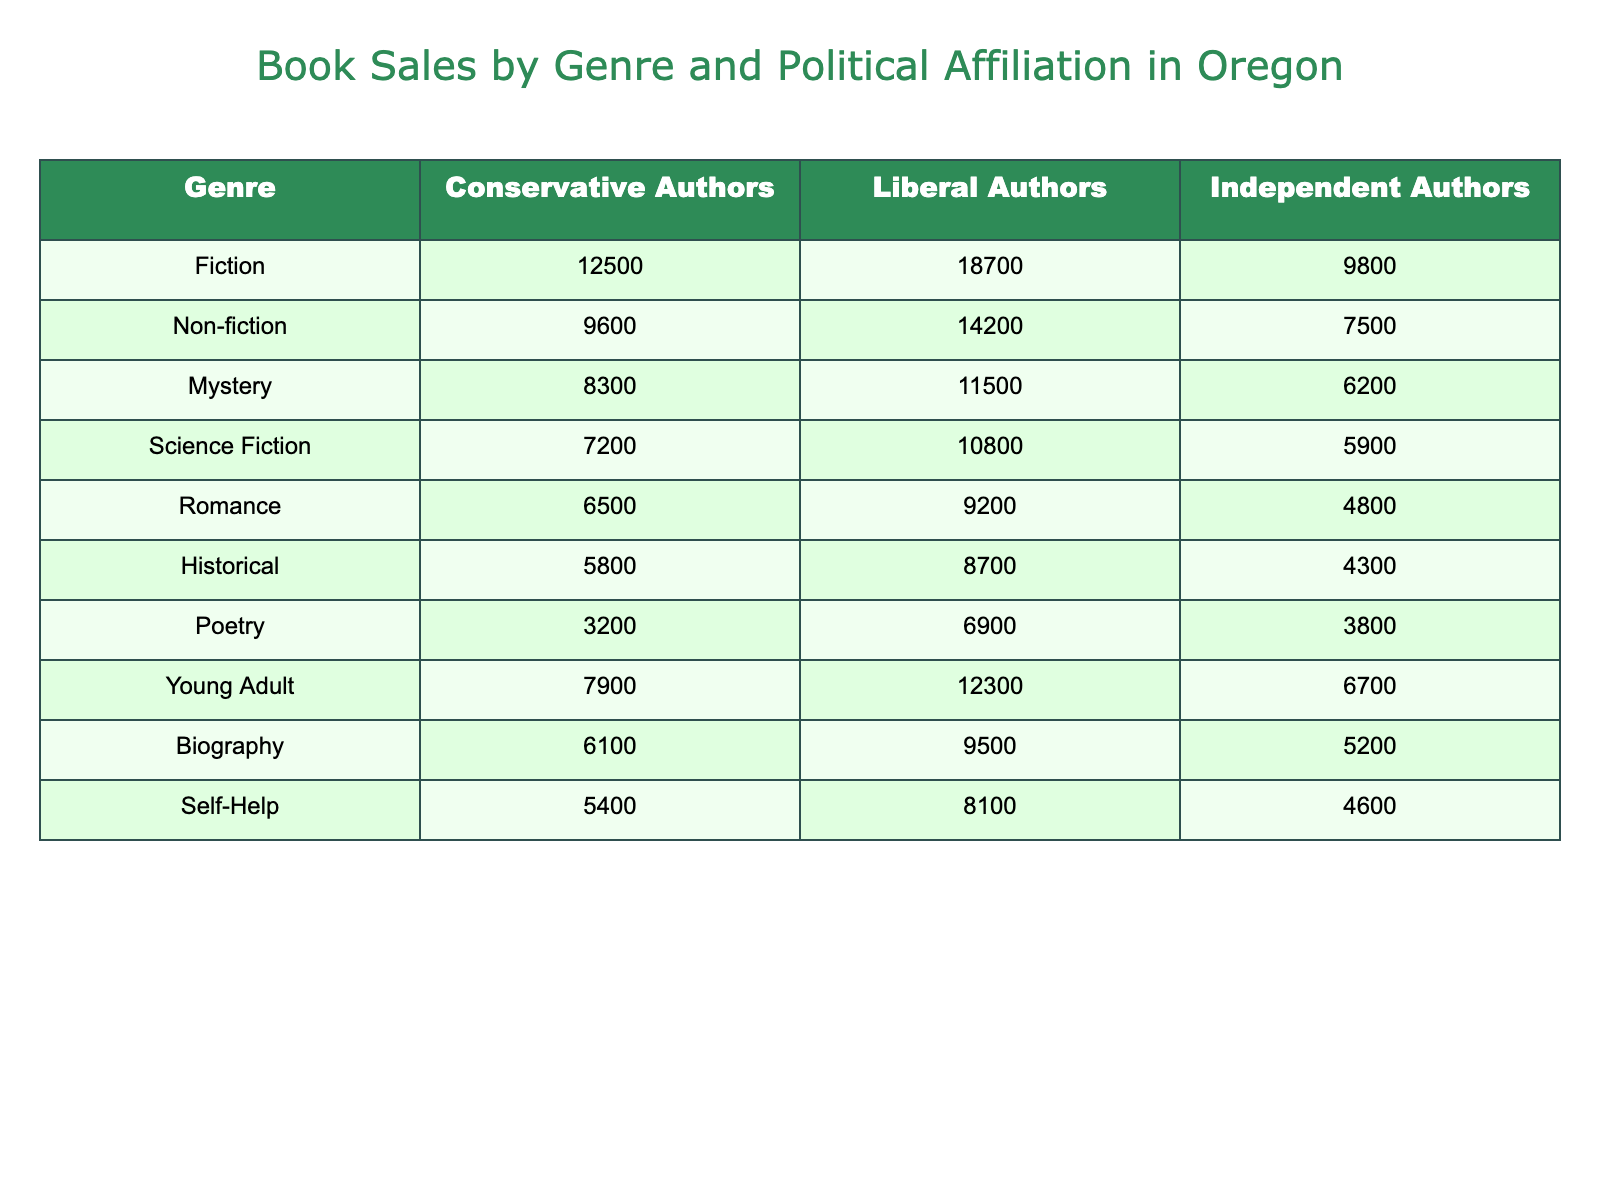What is the total number of book sales for Conservative authors in the Fiction genre? The table shows that Conservative authors sold 12,500 books in the Fiction genre, so that is the total number of book sales for that category.
Answer: 12500 What genre has the highest book sales for Liberal authors? Among the genres listed, Fiction has the highest sales figure for Liberal authors at 18,700 books, which is more than any other genre.
Answer: Fiction How many more books did Liberal authors sell compared to Conservative authors in the Non-fiction genre? Looking at the Non-fiction genre, Liberal authors sold 14,200 books while Conservative authors sold 9,600 books. The difference is 14,200 - 9,600 = 4,600 books.
Answer: 4600 What are the total book sales combined for Independent Authors across all genres? By adding the sales of Independent Authors from each genre: 9,800 + 7,500 + 6,200 + 5,900 + 4,800 + 4,300 + 3,800 + 6,700 + 5,200 + 4,600, we find that the total is 58,800 books.
Answer: 58800 In the Mystery genre, do Liberal authors have a higher book sales figure than Independent authors? Liberal authors sold 11,500 books while Independent authors sold 6,200 books in the Mystery genre. Since 11,500 is greater than 6,200, the statement is true.
Answer: Yes What is the average book sales figure for Conservative authors across all genres? To find the average, add the book sales for Conservative authors (12,500 + 9,600 + 8,300 + 7,200 + 6,500 + 5,800 + 3,200 + 7,900 + 6,100 + 5,400), which totals 66,700. Dividing by the 10 genres gives 66,700 / 10 = 6,670.
Answer: 6670 Which genre has the largest difference in book sales between Liberal and Conservative authors? By calculating the differences for each genre, the largest difference is in the Fiction genre with a difference of 18,700 - 12,500 = 6,200 books, which is greater than the differences in all other genres.
Answer: Fiction Is the total number of book sales higher for Liberal authors compared to Independent authors? Totaling the sales for Liberal authors gives 100,000 books (18,700 + 14,200 + 11,500 + 10,800 + 9,200 + 8,700 + 6,900 + 12,300 + 9,500 + 8,100) and for Independent authors gives 58,800 books. Since 100,000 is greater than 58,800, the answer is yes.
Answer: Yes What is the sales ratio of Romance books between Liberal and Conservative authors? For Romance, Liberal authors sold 9,200 books and Conservative authors sold 6,500. The ratio is 9,200 to 6,500, which simplifies to approximately 1.42 when calculated (9,200 / 6,500).
Answer: 1.42 Which political affiliation sold the fewest books in the Historical genre? In the Historical genre, Conservative authors sold 5,800, Liberal authors sold 8,700, and Independent authors sold 4,300. Comparing these, Independent authors sold the fewest books.
Answer: Independent Authors 